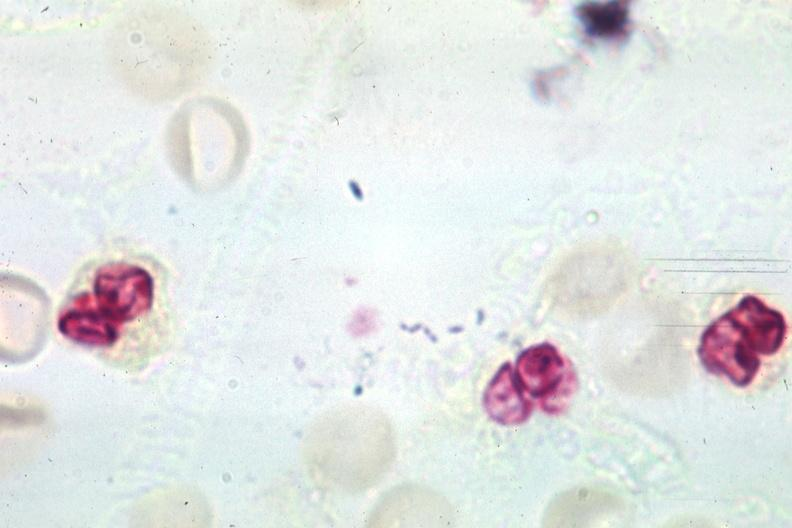s spinal fluid present?
Answer the question using a single word or phrase. Yes 